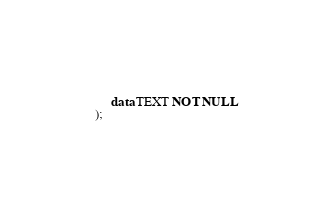Convert code to text. <code><loc_0><loc_0><loc_500><loc_500><_SQL_>     data TEXT NOT NULL
);</code> 